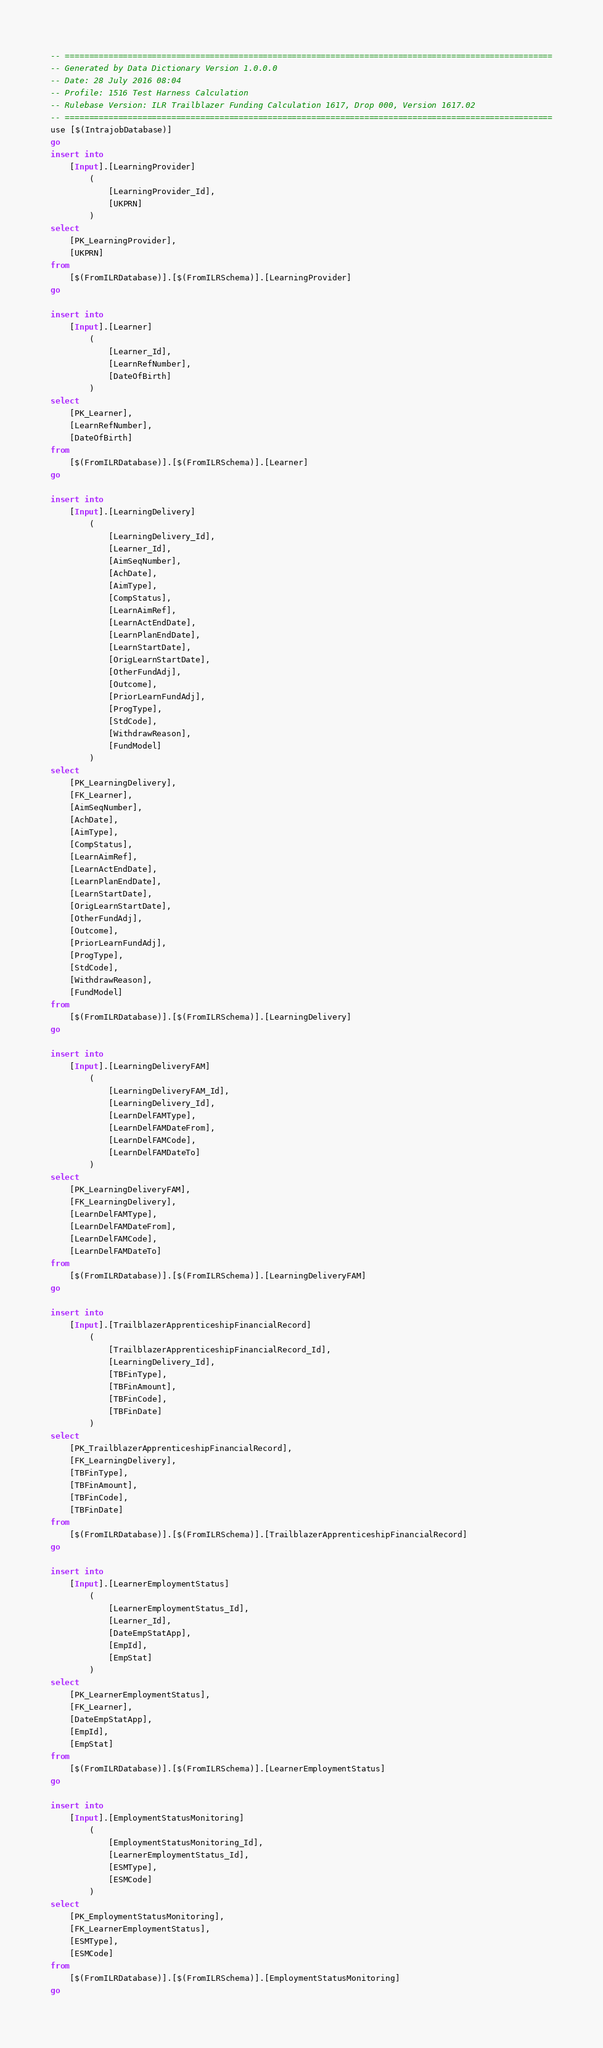Convert code to text. <code><loc_0><loc_0><loc_500><loc_500><_SQL_>-- =====================================================================================================
-- Generated by Data Dictionary Version 1.0.0.0
-- Date: 28 July 2016 08:04
-- Profile: 1516 Test Harness Calculation
-- Rulebase Version: ILR Trailblazer Funding Calculation 1617, Drop 000, Version 1617.02
-- =====================================================================================================
use [$(IntrajobDatabase)]
go
insert into
	[Input].[LearningProvider]
		(
			[LearningProvider_Id],
			[UKPRN]
		)
select
	[PK_LearningProvider],
	[UKPRN]
from
	[$(FromILRDatabase)].[$(FromILRSchema)].[LearningProvider]
go

insert into
	[Input].[Learner]
		(
			[Learner_Id],
			[LearnRefNumber],
			[DateOfBirth]
		)
select
	[PK_Learner],
	[LearnRefNumber],
	[DateOfBirth]
from
	[$(FromILRDatabase)].[$(FromILRSchema)].[Learner]
go

insert into
	[Input].[LearningDelivery]
		(
			[LearningDelivery_Id],
			[Learner_Id],
			[AimSeqNumber],
			[AchDate],
			[AimType],
			[CompStatus],
			[LearnAimRef],
			[LearnActEndDate],
			[LearnPlanEndDate],
			[LearnStartDate],
			[OrigLearnStartDate],
			[OtherFundAdj],
			[Outcome],
			[PriorLearnFundAdj],
			[ProgType],
			[StdCode],
			[WithdrawReason],
			[FundModel]
		)
select
	[PK_LearningDelivery],
	[FK_Learner],
	[AimSeqNumber],
	[AchDate],
	[AimType],
	[CompStatus],
	[LearnAimRef],
	[LearnActEndDate],
	[LearnPlanEndDate],
	[LearnStartDate],
	[OrigLearnStartDate],
	[OtherFundAdj],
	[Outcome],
	[PriorLearnFundAdj],
	[ProgType],
	[StdCode],
	[WithdrawReason],
	[FundModel]
from
	[$(FromILRDatabase)].[$(FromILRSchema)].[LearningDelivery]
go

insert into
	[Input].[LearningDeliveryFAM]
		(
			[LearningDeliveryFAM_Id],
			[LearningDelivery_Id],
			[LearnDelFAMType],
			[LearnDelFAMDateFrom],
			[LearnDelFAMCode],
			[LearnDelFAMDateTo]
		)
select
	[PK_LearningDeliveryFAM],
	[FK_LearningDelivery],
	[LearnDelFAMType],
	[LearnDelFAMDateFrom],
	[LearnDelFAMCode],
	[LearnDelFAMDateTo]
from
	[$(FromILRDatabase)].[$(FromILRSchema)].[LearningDeliveryFAM]
go

insert into
	[Input].[TrailblazerApprenticeshipFinancialRecord]
		(
			[TrailblazerApprenticeshipFinancialRecord_Id],
			[LearningDelivery_Id],
			[TBFinType],
			[TBFinAmount],
			[TBFinCode],
			[TBFinDate]
		)
select
	[PK_TrailblazerApprenticeshipFinancialRecord],
	[FK_LearningDelivery],
	[TBFinType],
	[TBFinAmount],
	[TBFinCode],
	[TBFinDate]
from
	[$(FromILRDatabase)].[$(FromILRSchema)].[TrailblazerApprenticeshipFinancialRecord]
go

insert into
	[Input].[LearnerEmploymentStatus]
		(
			[LearnerEmploymentStatus_Id],
			[Learner_Id],
			[DateEmpStatApp],
			[EmpId],
			[EmpStat]
		)
select
	[PK_LearnerEmploymentStatus],
	[FK_Learner],
	[DateEmpStatApp],
	[EmpId],
	[EmpStat]
from
	[$(FromILRDatabase)].[$(FromILRSchema)].[LearnerEmploymentStatus]
go

insert into
	[Input].[EmploymentStatusMonitoring]
		(
			[EmploymentStatusMonitoring_Id],
			[LearnerEmploymentStatus_Id],
			[ESMType],
			[ESMCode]
		)
select
	[PK_EmploymentStatusMonitoring],
	[FK_LearnerEmploymentStatus],
	[ESMType],
	[ESMCode]
from
	[$(FromILRDatabase)].[$(FromILRSchema)].[EmploymentStatusMonitoring]
go

</code> 